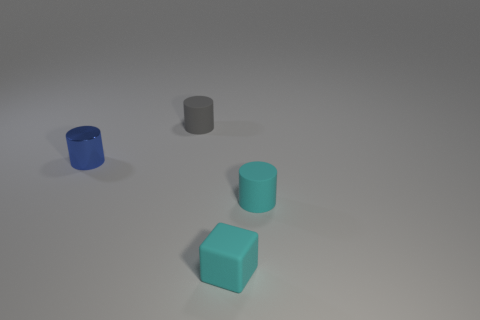What is the material of the cylinder that is both in front of the gray rubber object and on the left side of the rubber block?
Make the answer very short. Metal. Are there any small gray objects that have the same shape as the blue object?
Your answer should be very brief. Yes. Is there a cyan matte object that is in front of the cylinder that is right of the gray cylinder?
Your answer should be very brief. Yes. What number of cyan cylinders have the same material as the small blue cylinder?
Your answer should be very brief. 0. Are there any small gray matte blocks?
Offer a terse response. No. How many other metallic things are the same color as the tiny metallic thing?
Give a very brief answer. 0. Is the cyan block made of the same material as the tiny thing on the left side of the small gray cylinder?
Your response must be concise. No. Is the number of tiny cyan blocks on the right side of the tiny gray matte cylinder greater than the number of green spheres?
Offer a terse response. Yes. There is a tiny block; is it the same color as the matte thing that is to the right of the small cyan block?
Keep it short and to the point. Yes. Are there the same number of cyan rubber cubes right of the small cyan rubber cube and shiny cylinders in front of the gray object?
Ensure brevity in your answer.  No. 